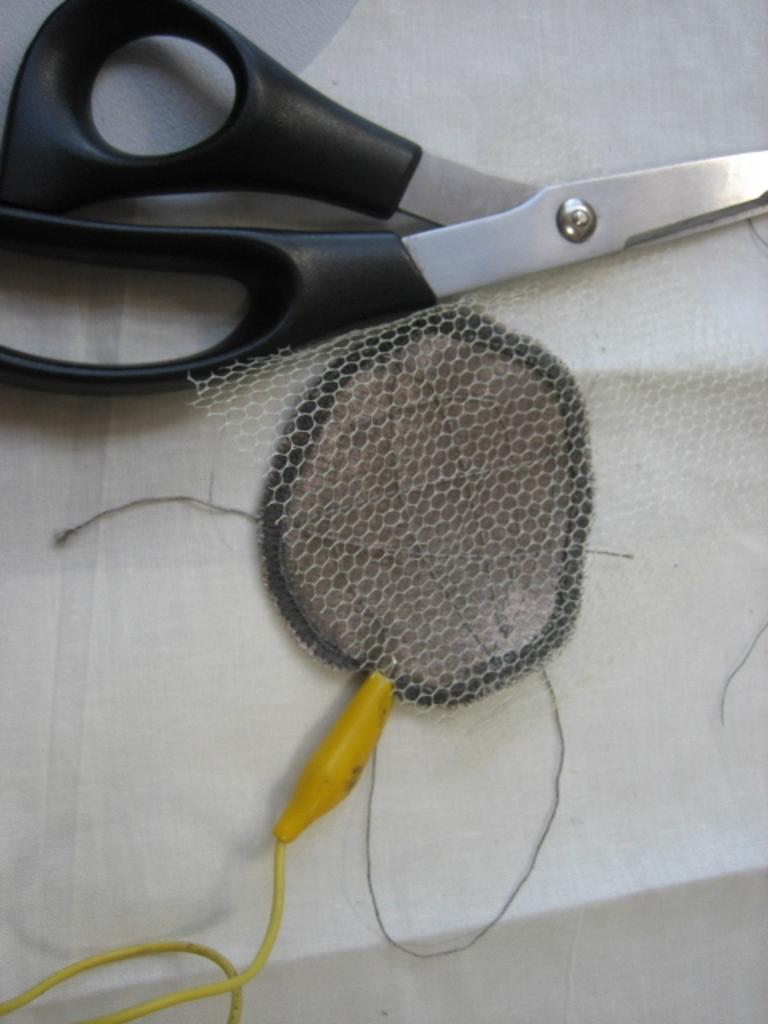What type of tool is visible in the image? There is a pair of scissors in the image. What else can be seen in the image besides the scissors? There is a net and a yellow color wire in the image. What is the color of the surface on which the objects are placed? The objects are placed on a white surface. How many flowers are present in the image? There are no flowers present in the image. What type of brush is used to paint the net in the image? There is no brush or painting activity depicted in the image; it only shows a net, a pair of scissors, and a yellow wire. 